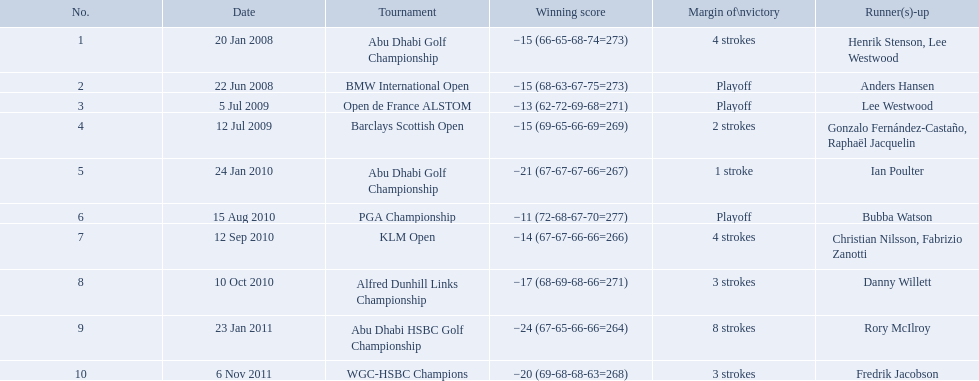What were the margins of victories of the tournaments? 4 strokes, Playoff, Playoff, 2 strokes, 1 stroke, Playoff, 4 strokes, 3 strokes, 8 strokes, 3 strokes. Of these, what was the margin of victory of the klm and the barklay 2 strokes, 4 strokes. What were the difference between these? 2 strokes. What were all of the tournaments martin played in? Abu Dhabi Golf Championship, BMW International Open, Open de France ALSTOM, Barclays Scottish Open, Abu Dhabi Golf Championship, PGA Championship, KLM Open, Alfred Dunhill Links Championship, Abu Dhabi HSBC Golf Championship, WGC-HSBC Champions. And how many strokes did he score? −15 (66-65-68-74=273), −15 (68-63-67-75=273), −13 (62-72-69-68=271), −15 (69-65-66-69=269), −21 (67-67-67-66=267), −11 (72-68-67-70=277), −14 (67-67-66-66=266), −17 (68-69-68-66=271), −24 (67-65-66-66=264), −20 (69-68-68-63=268). What about during barclays and klm? −15 (69-65-66-69=269), −14 (67-67-66-66=266). How many more were scored in klm? 2 strokes. What are all of the tournaments? Abu Dhabi Golf Championship, BMW International Open, Open de France ALSTOM, Barclays Scottish Open, Abu Dhabi Golf Championship, PGA Championship, KLM Open, Alfred Dunhill Links Championship, Abu Dhabi HSBC Golf Championship, WGC-HSBC Champions. What was the score during each? −15 (66-65-68-74=273), −15 (68-63-67-75=273), −13 (62-72-69-68=271), −15 (69-65-66-69=269), −21 (67-67-67-66=267), −11 (72-68-67-70=277), −14 (67-67-66-66=266), −17 (68-69-68-66=271), −24 (67-65-66-66=264), −20 (69-68-68-63=268). And who was the runner-up in each? Henrik Stenson, Lee Westwood, Anders Hansen, Lee Westwood, Gonzalo Fernández-Castaño, Raphaël Jacquelin, Ian Poulter, Bubba Watson, Christian Nilsson, Fabrizio Zanotti, Danny Willett, Rory McIlroy, Fredrik Jacobson. What about just during pga games? Bubba Watson. In which tournaments did martin compete? Abu Dhabi Golf Championship, BMW International Open, Open de France ALSTOM, Barclays Scottish Open, Abu Dhabi Golf Championship, PGA Championship, KLM Open, Alfred Dunhill Links Championship, Abu Dhabi HSBC Golf Championship, WGC-HSBC Champions. And what was his stroke count? −15 (66-65-68-74=273), −15 (68-63-67-75=273), −13 (62-72-69-68=271), −15 (69-65-66-69=269), −21 (67-67-67-66=267), −11 (72-68-67-70=277), −14 (67-67-66-66=266), −17 (68-69-68-66=271), −24 (67-65-66-66=264), −20 (69-68-68-63=268). What about in barclays and klm? −15 (69-65-66-69=269), −14 (67-67-66-66=266). How many extra strokes were recorded in klm? 2 strokes. What was the stroke count for martin kaymer at the klm open? 4 strokes. How many strokes were played at the abu dhabi golf championship? 4 strokes. How many additional strokes were there at the klm compared to the barclays open? 2 strokes. 